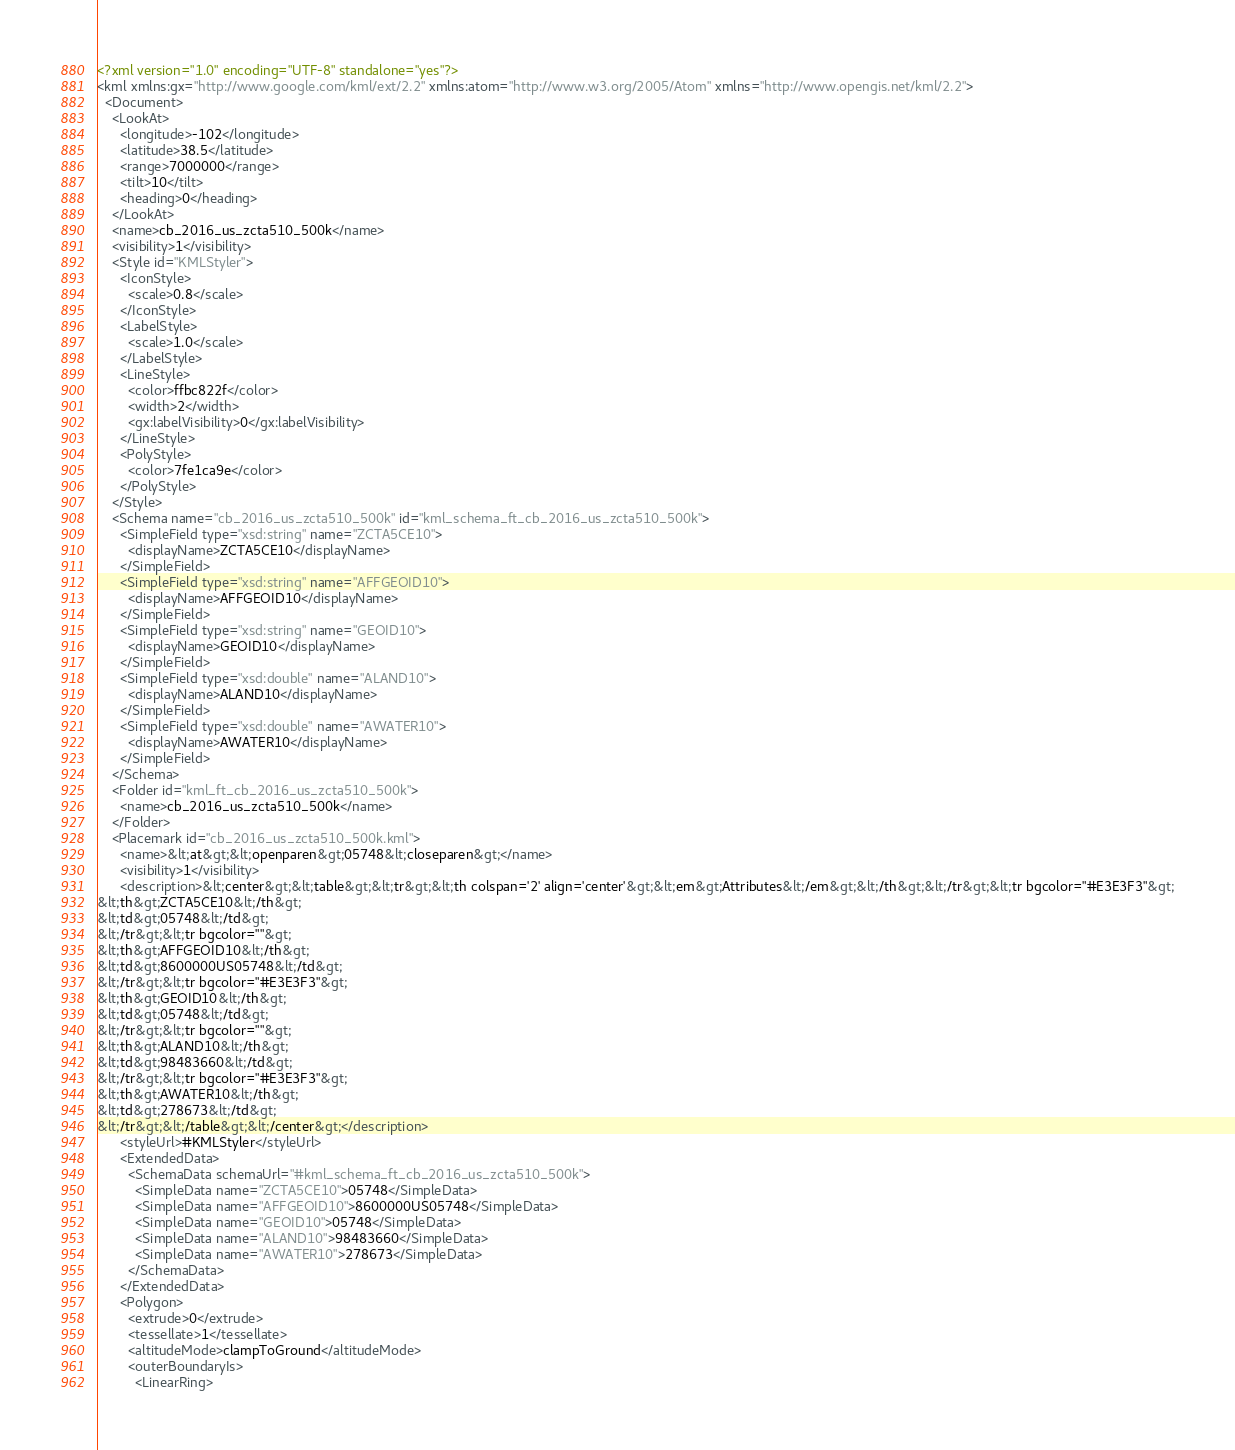Convert code to text. <code><loc_0><loc_0><loc_500><loc_500><_XML_><?xml version="1.0" encoding="UTF-8" standalone="yes"?>
<kml xmlns:gx="http://www.google.com/kml/ext/2.2" xmlns:atom="http://www.w3.org/2005/Atom" xmlns="http://www.opengis.net/kml/2.2">
  <Document>
    <LookAt>
      <longitude>-102</longitude>
      <latitude>38.5</latitude>
      <range>7000000</range>
      <tilt>10</tilt>
      <heading>0</heading>
    </LookAt>
    <name>cb_2016_us_zcta510_500k</name>
    <visibility>1</visibility>
    <Style id="KMLStyler">
      <IconStyle>
        <scale>0.8</scale>
      </IconStyle>
      <LabelStyle>
        <scale>1.0</scale>
      </LabelStyle>
      <LineStyle>
        <color>ffbc822f</color>
        <width>2</width>
        <gx:labelVisibility>0</gx:labelVisibility>
      </LineStyle>
      <PolyStyle>
        <color>7fe1ca9e</color>
      </PolyStyle>
    </Style>
    <Schema name="cb_2016_us_zcta510_500k" id="kml_schema_ft_cb_2016_us_zcta510_500k">
      <SimpleField type="xsd:string" name="ZCTA5CE10">
        <displayName>ZCTA5CE10</displayName>
      </SimpleField>
      <SimpleField type="xsd:string" name="AFFGEOID10">
        <displayName>AFFGEOID10</displayName>
      </SimpleField>
      <SimpleField type="xsd:string" name="GEOID10">
        <displayName>GEOID10</displayName>
      </SimpleField>
      <SimpleField type="xsd:double" name="ALAND10">
        <displayName>ALAND10</displayName>
      </SimpleField>
      <SimpleField type="xsd:double" name="AWATER10">
        <displayName>AWATER10</displayName>
      </SimpleField>
    </Schema>
    <Folder id="kml_ft_cb_2016_us_zcta510_500k">
      <name>cb_2016_us_zcta510_500k</name>
    </Folder>
    <Placemark id="cb_2016_us_zcta510_500k.kml">
      <name>&lt;at&gt;&lt;openparen&gt;05748&lt;closeparen&gt;</name>
      <visibility>1</visibility>
      <description>&lt;center&gt;&lt;table&gt;&lt;tr&gt;&lt;th colspan='2' align='center'&gt;&lt;em&gt;Attributes&lt;/em&gt;&lt;/th&gt;&lt;/tr&gt;&lt;tr bgcolor="#E3E3F3"&gt;
&lt;th&gt;ZCTA5CE10&lt;/th&gt;
&lt;td&gt;05748&lt;/td&gt;
&lt;/tr&gt;&lt;tr bgcolor=""&gt;
&lt;th&gt;AFFGEOID10&lt;/th&gt;
&lt;td&gt;8600000US05748&lt;/td&gt;
&lt;/tr&gt;&lt;tr bgcolor="#E3E3F3"&gt;
&lt;th&gt;GEOID10&lt;/th&gt;
&lt;td&gt;05748&lt;/td&gt;
&lt;/tr&gt;&lt;tr bgcolor=""&gt;
&lt;th&gt;ALAND10&lt;/th&gt;
&lt;td&gt;98483660&lt;/td&gt;
&lt;/tr&gt;&lt;tr bgcolor="#E3E3F3"&gt;
&lt;th&gt;AWATER10&lt;/th&gt;
&lt;td&gt;278673&lt;/td&gt;
&lt;/tr&gt;&lt;/table&gt;&lt;/center&gt;</description>
      <styleUrl>#KMLStyler</styleUrl>
      <ExtendedData>
        <SchemaData schemaUrl="#kml_schema_ft_cb_2016_us_zcta510_500k">
          <SimpleData name="ZCTA5CE10">05748</SimpleData>
          <SimpleData name="AFFGEOID10">8600000US05748</SimpleData>
          <SimpleData name="GEOID10">05748</SimpleData>
          <SimpleData name="ALAND10">98483660</SimpleData>
          <SimpleData name="AWATER10">278673</SimpleData>
        </SchemaData>
      </ExtendedData>
      <Polygon>
        <extrude>0</extrude>
        <tessellate>1</tessellate>
        <altitudeMode>clampToGround</altitudeMode>
        <outerBoundaryIs>
          <LinearRing></code> 